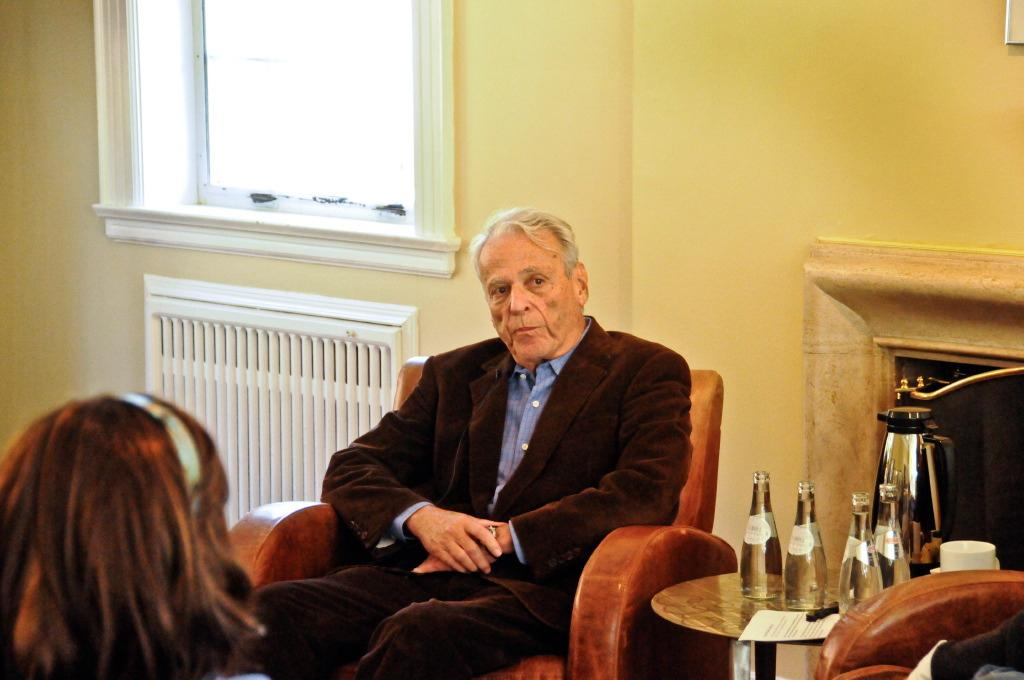What color is the wall in the image? The wall in the image is yellow. What can be seen on the wall in the image? There is a window on the wall in the image. How many people are sitting in the image? There are two people sitting on sofas in the image. What furniture is present in the image? There is a table in the image. What items are on the table in the image? There are bottles and a cup on the table in the image. What type of skirt is hanging on the wall in the image? There is no skirt present in the image; the wall is yellow and has a window on it. 